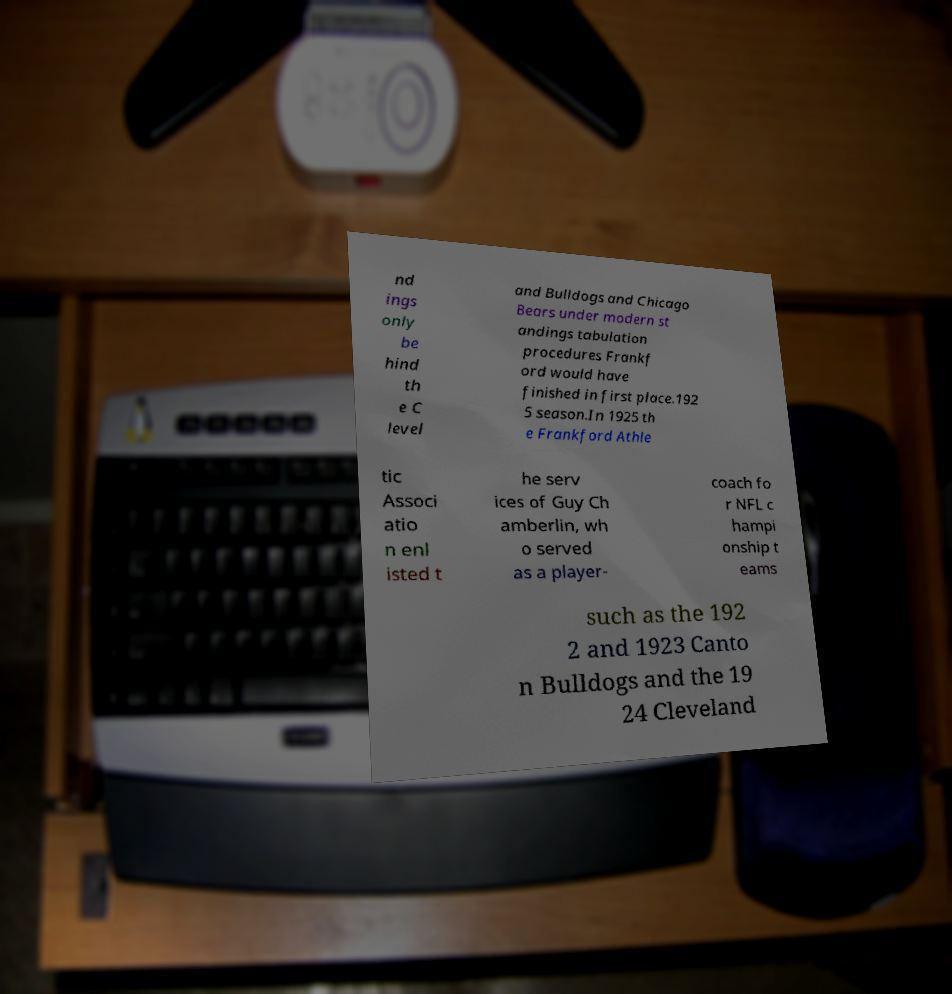There's text embedded in this image that I need extracted. Can you transcribe it verbatim? nd ings only be hind th e C level and Bulldogs and Chicago Bears under modern st andings tabulation procedures Frankf ord would have finished in first place.192 5 season.In 1925 th e Frankford Athle tic Associ atio n enl isted t he serv ices of Guy Ch amberlin, wh o served as a player- coach fo r NFL c hampi onship t eams such as the 192 2 and 1923 Canto n Bulldogs and the 19 24 Cleveland 